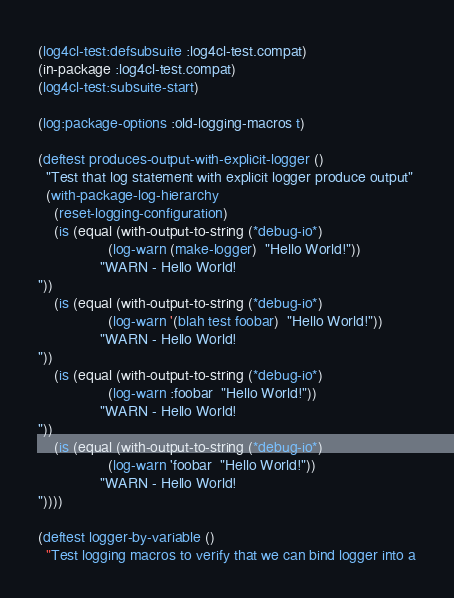Convert code to text. <code><loc_0><loc_0><loc_500><loc_500><_Lisp_>(log4cl-test:defsubsuite :log4cl-test.compat)
(in-package :log4cl-test.compat)
(log4cl-test:subsuite-start)

(log:package-options :old-logging-macros t)

(deftest produces-output-with-explicit-logger ()
  "Test that log statement with explicit logger produce output"
  (with-package-log-hierarchy
    (reset-logging-configuration)
    (is (equal (with-output-to-string (*debug-io*)
                 (log-warn (make-logger)  "Hello World!"))
               "WARN - Hello World!
"))
    (is (equal (with-output-to-string (*debug-io*)
                 (log-warn '(blah test foobar)  "Hello World!"))
               "WARN - Hello World!
"))
    (is (equal (with-output-to-string (*debug-io*)
                 (log-warn :foobar  "Hello World!"))
               "WARN - Hello World!
"))
    (is (equal (with-output-to-string (*debug-io*)
                 (log-warn 'foobar  "Hello World!"))
               "WARN - Hello World!
"))))

(deftest logger-by-variable ()
  "Test logging macros to verify that we can bind logger into a</code> 